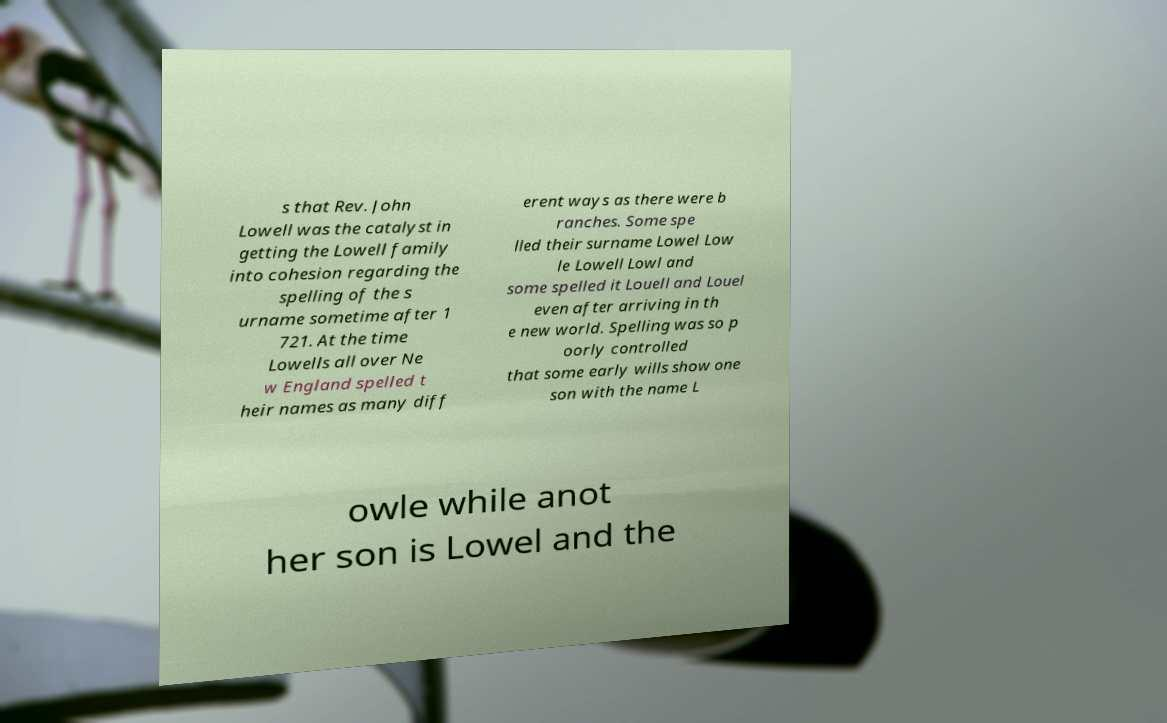Could you extract and type out the text from this image? s that Rev. John Lowell was the catalyst in getting the Lowell family into cohesion regarding the spelling of the s urname sometime after 1 721. At the time Lowells all over Ne w England spelled t heir names as many diff erent ways as there were b ranches. Some spe lled their surname Lowel Low le Lowell Lowl and some spelled it Louell and Louel even after arriving in th e new world. Spelling was so p oorly controlled that some early wills show one son with the name L owle while anot her son is Lowel and the 